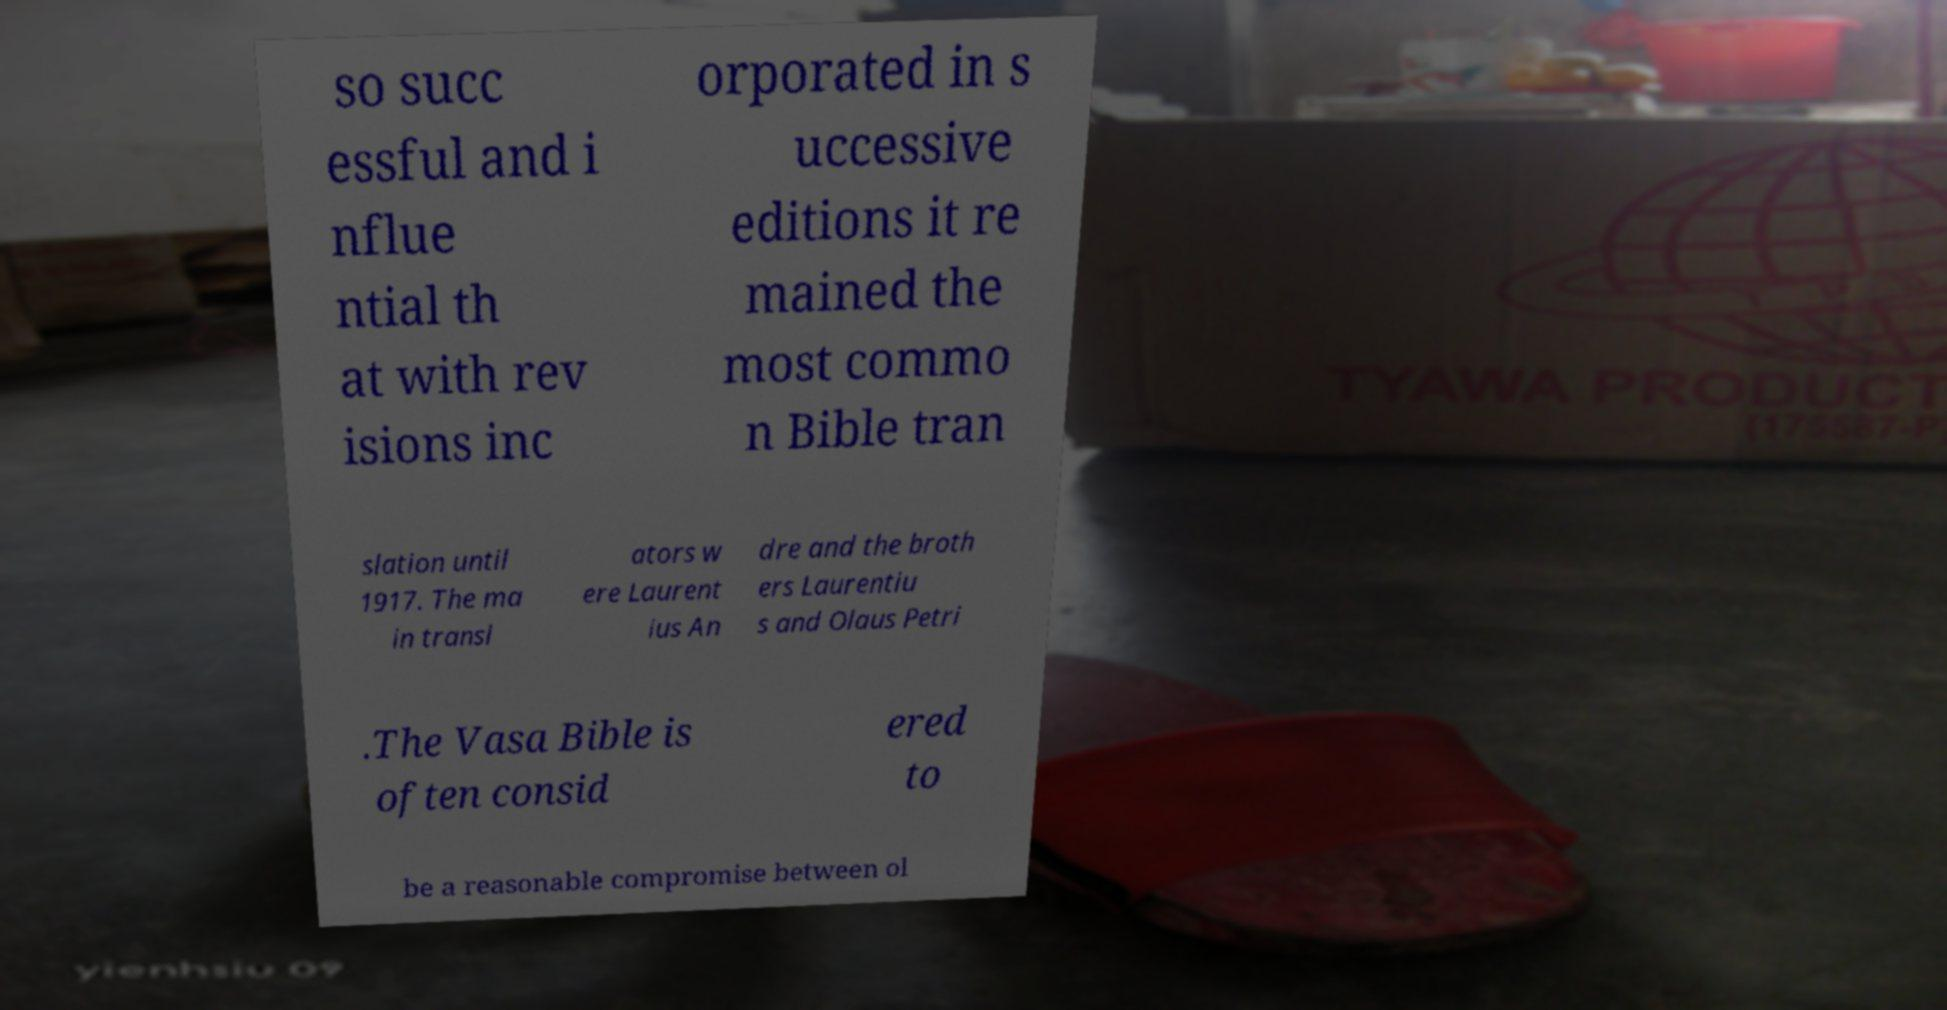Please read and relay the text visible in this image. What does it say? so succ essful and i nflue ntial th at with rev isions inc orporated in s uccessive editions it re mained the most commo n Bible tran slation until 1917. The ma in transl ators w ere Laurent ius An dre and the broth ers Laurentiu s and Olaus Petri .The Vasa Bible is often consid ered to be a reasonable compromise between ol 